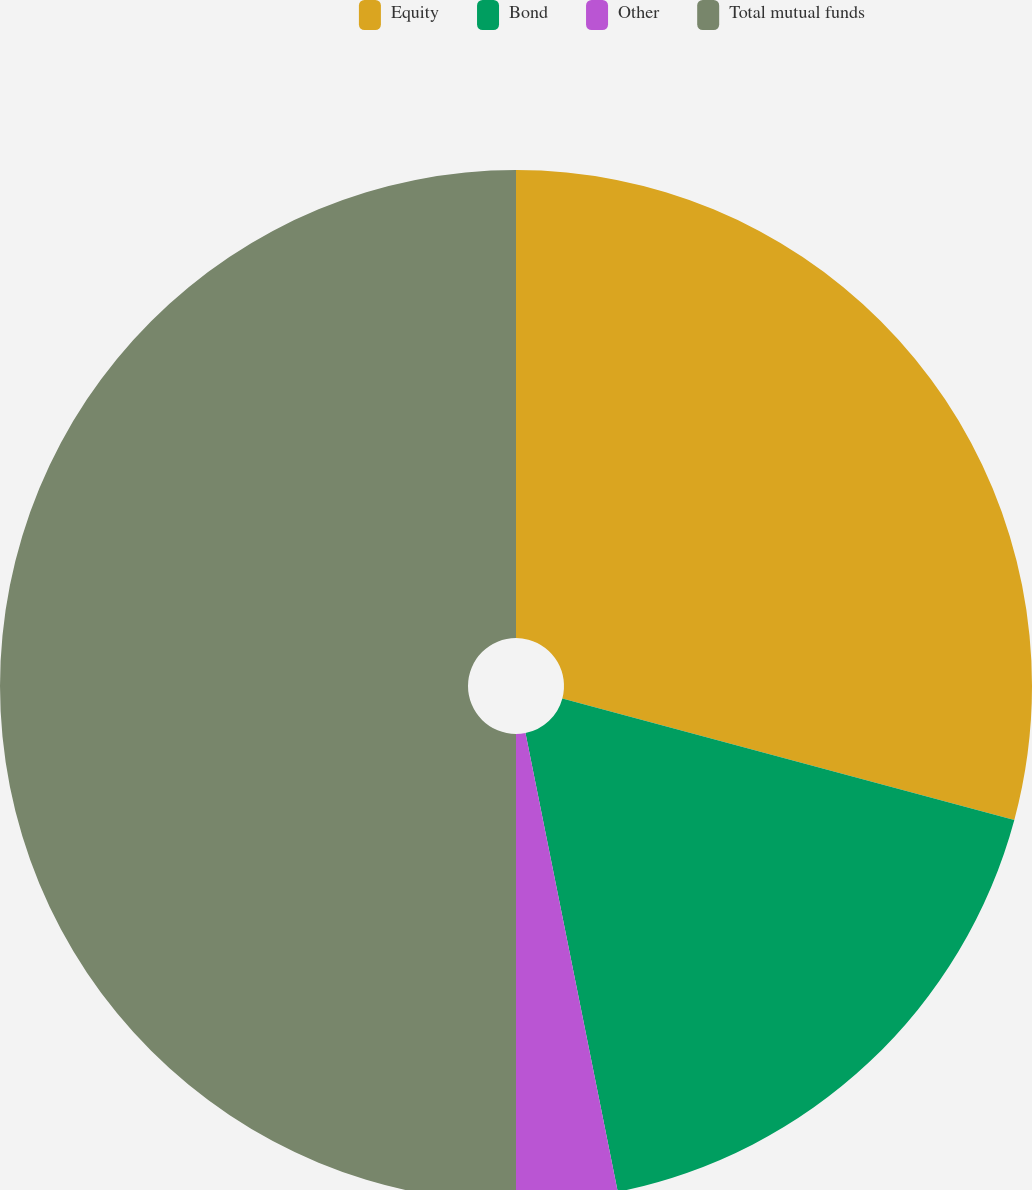Convert chart to OTSL. <chart><loc_0><loc_0><loc_500><loc_500><pie_chart><fcel>Equity<fcel>Bond<fcel>Other<fcel>Total mutual funds<nl><fcel>29.18%<fcel>17.66%<fcel>3.16%<fcel>50.0%<nl></chart> 